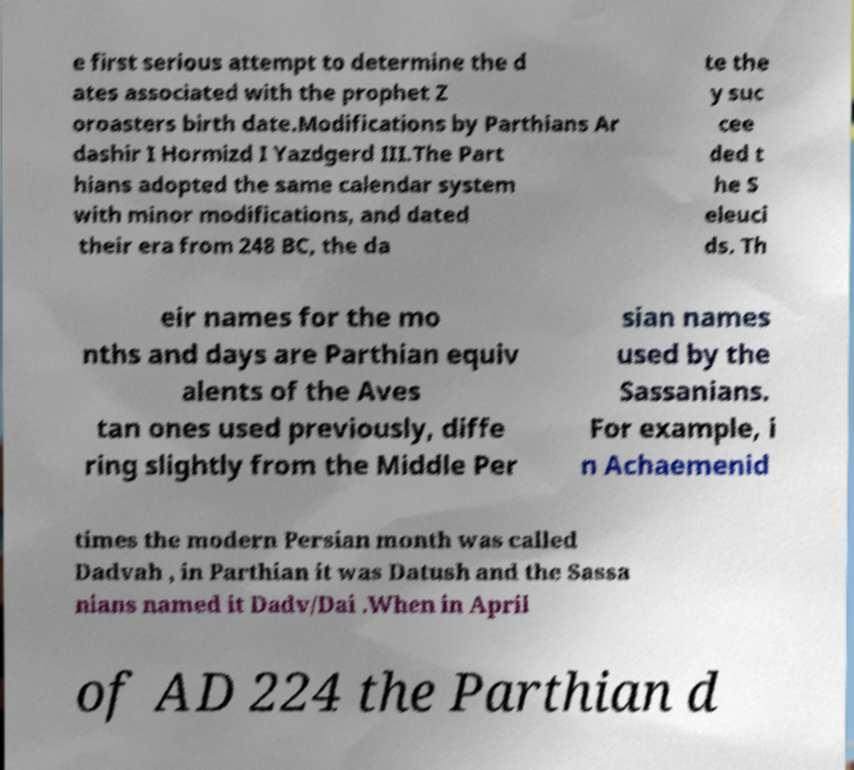Please read and relay the text visible in this image. What does it say? e first serious attempt to determine the d ates associated with the prophet Z oroasters birth date.Modifications by Parthians Ar dashir I Hormizd I Yazdgerd III.The Part hians adopted the same calendar system with minor modifications, and dated their era from 248 BC, the da te the y suc cee ded t he S eleuci ds. Th eir names for the mo nths and days are Parthian equiv alents of the Aves tan ones used previously, diffe ring slightly from the Middle Per sian names used by the Sassanians. For example, i n Achaemenid times the modern Persian month was called Dadvah , in Parthian it was Datush and the Sassa nians named it Dadv/Dai .When in April of AD 224 the Parthian d 